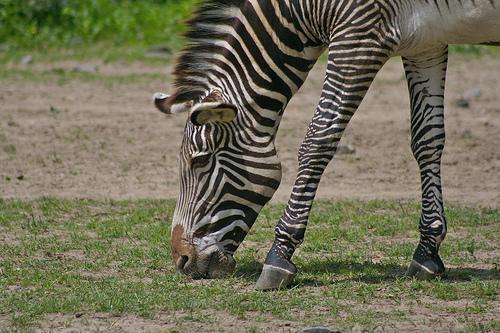How many zebras are there?
Give a very brief answer. 1. 